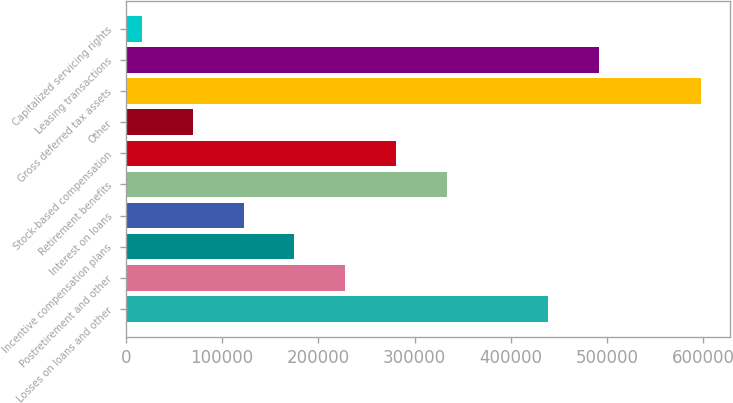Convert chart. <chart><loc_0><loc_0><loc_500><loc_500><bar_chart><fcel>Losses on loans and other<fcel>Postretirement and other<fcel>Incentive compensation plans<fcel>Interest on loans<fcel>Retirement benefits<fcel>Stock-based compensation<fcel>Other<fcel>Gross deferred tax assets<fcel>Leasing transactions<fcel>Capitalized servicing rights<nl><fcel>439154<fcel>228059<fcel>175285<fcel>122512<fcel>333607<fcel>280833<fcel>69737.8<fcel>597476<fcel>491928<fcel>16964<nl></chart> 